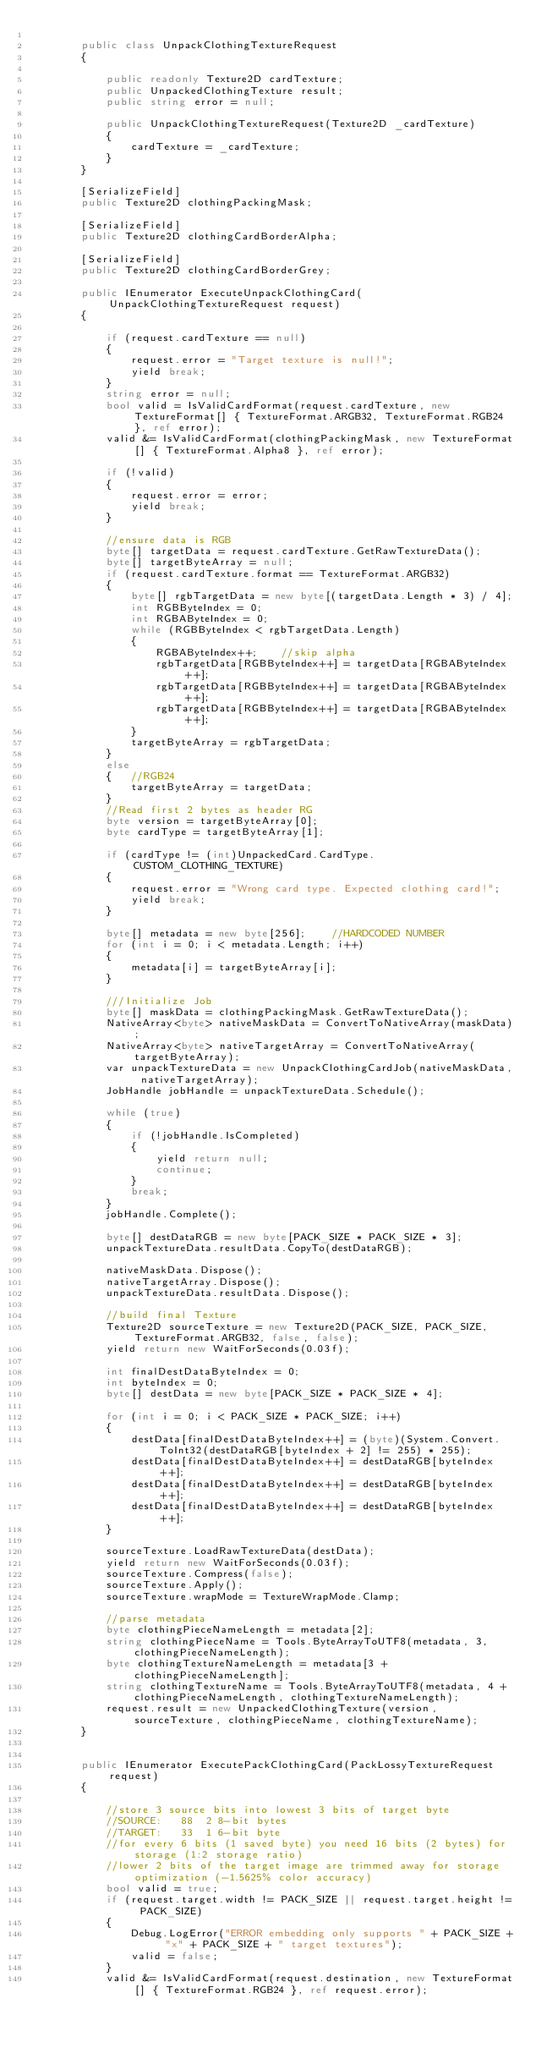<code> <loc_0><loc_0><loc_500><loc_500><_C#_>
        public class UnpackClothingTextureRequest
        {

            public readonly Texture2D cardTexture;
            public UnpackedClothingTexture result;
            public string error = null;

            public UnpackClothingTextureRequest(Texture2D _cardTexture)
            {
                cardTexture = _cardTexture;
            }
        }

        [SerializeField]
        public Texture2D clothingPackingMask;

        [SerializeField]
        public Texture2D clothingCardBorderAlpha;

        [SerializeField]
        public Texture2D clothingCardBorderGrey;

        public IEnumerator ExecuteUnpackClothingCard(UnpackClothingTextureRequest request)
        {

            if (request.cardTexture == null)
            {
                request.error = "Target texture is null!";
                yield break;
            }
            string error = null;
            bool valid = IsValidCardFormat(request.cardTexture, new TextureFormat[] { TextureFormat.ARGB32, TextureFormat.RGB24 }, ref error);
            valid &= IsValidCardFormat(clothingPackingMask, new TextureFormat[] { TextureFormat.Alpha8 }, ref error);

            if (!valid)
            {
                request.error = error;
                yield break;
            }

            //ensure data is RGB
            byte[] targetData = request.cardTexture.GetRawTextureData();
            byte[] targetByteArray = null;
            if (request.cardTexture.format == TextureFormat.ARGB32)
            {
                byte[] rgbTargetData = new byte[(targetData.Length * 3) / 4];
                int RGBByteIndex = 0;
                int RGBAByteIndex = 0;
                while (RGBByteIndex < rgbTargetData.Length)
                {
                    RGBAByteIndex++;    //skip alpha
                    rgbTargetData[RGBByteIndex++] = targetData[RGBAByteIndex++];
                    rgbTargetData[RGBByteIndex++] = targetData[RGBAByteIndex++];
                    rgbTargetData[RGBByteIndex++] = targetData[RGBAByteIndex++];
                }
                targetByteArray = rgbTargetData;
            }
            else
            {   //RGB24
                targetByteArray = targetData;
            }
            //Read first 2 bytes as header RG
            byte version = targetByteArray[0];
            byte cardType = targetByteArray[1];

            if (cardType != (int)UnpackedCard.CardType.CUSTOM_CLOTHING_TEXTURE)
            {
                request.error = "Wrong card type. Expected clothing card!";
                yield break;
            }

            byte[] metadata = new byte[256];    //HARDCODED NUMBER
            for (int i = 0; i < metadata.Length; i++)
            {
                metadata[i] = targetByteArray[i];
            }

            ///Initialize Job
            byte[] maskData = clothingPackingMask.GetRawTextureData();
            NativeArray<byte> nativeMaskData = ConvertToNativeArray(maskData);
            NativeArray<byte> nativeTargetArray = ConvertToNativeArray(targetByteArray);
            var unpackTextureData = new UnpackClothingCardJob(nativeMaskData, nativeTargetArray);
            JobHandle jobHandle = unpackTextureData.Schedule();

            while (true)
            {
                if (!jobHandle.IsCompleted)
                {
                    yield return null;
                    continue;
                }
                break;
            }
            jobHandle.Complete();

            byte[] destDataRGB = new byte[PACK_SIZE * PACK_SIZE * 3];
            unpackTextureData.resultData.CopyTo(destDataRGB);

            nativeMaskData.Dispose();
            nativeTargetArray.Dispose();
            unpackTextureData.resultData.Dispose();

            //build final Texture
            Texture2D sourceTexture = new Texture2D(PACK_SIZE, PACK_SIZE, TextureFormat.ARGB32, false, false);
            yield return new WaitForSeconds(0.03f);

            int finalDestDataByteIndex = 0;
            int byteIndex = 0;
            byte[] destData = new byte[PACK_SIZE * PACK_SIZE * 4];

            for (int i = 0; i < PACK_SIZE * PACK_SIZE; i++)
            {
                destData[finalDestDataByteIndex++] = (byte)(System.Convert.ToInt32(destDataRGB[byteIndex + 2] != 255) * 255);
                destData[finalDestDataByteIndex++] = destDataRGB[byteIndex++];
                destData[finalDestDataByteIndex++] = destDataRGB[byteIndex++];
                destData[finalDestDataByteIndex++] = destDataRGB[byteIndex++];
            }

            sourceTexture.LoadRawTextureData(destData);
            yield return new WaitForSeconds(0.03f);
            sourceTexture.Compress(false);
            sourceTexture.Apply();
            sourceTexture.wrapMode = TextureWrapMode.Clamp;

            //parse metadata
            byte clothingPieceNameLength = metadata[2];
            string clothingPieceName = Tools.ByteArrayToUTF8(metadata, 3, clothingPieceNameLength);
            byte clothingTextureNameLength = metadata[3 + clothingPieceNameLength];
            string clothingTextureName = Tools.ByteArrayToUTF8(metadata, 4 + clothingPieceNameLength, clothingTextureNameLength);
            request.result = new UnpackedClothingTexture(version, sourceTexture, clothingPieceName, clothingTextureName);
        }


        public IEnumerator ExecutePackClothingCard(PackLossyTextureRequest request)
        {

            //store 3 source bits into lowest 3 bits of target byte
            //SOURCE:   88	2 8-bit bytes
            //TARGET:   33	1 6-bit byte
            //for every 6 bits (1 saved byte) you need 16 bits (2 bytes) for storage (1:2 storage ratio)
            //lower 2 bits of the target image are trimmed away for storage optimization (-1.5625% color accuracy)
            bool valid = true;
            if (request.target.width != PACK_SIZE || request.target.height != PACK_SIZE)
            {
                Debug.LogError("ERROR embedding only supports " + PACK_SIZE + "x" + PACK_SIZE + " target textures");
                valid = false;
            }
            valid &= IsValidCardFormat(request.destination, new TextureFormat[] { TextureFormat.RGB24 }, ref request.error);</code> 